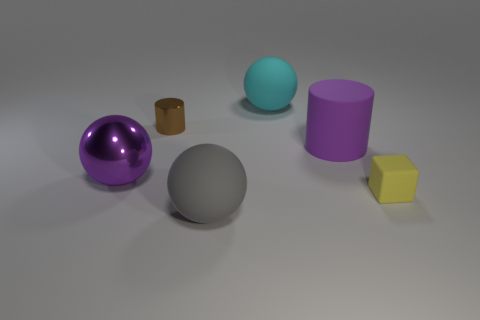Add 4 tiny shiny things. How many objects exist? 10 Subtract all cylinders. How many objects are left? 4 Subtract 0 green spheres. How many objects are left? 6 Subtract all big cyan spheres. Subtract all large matte cylinders. How many objects are left? 4 Add 6 large matte things. How many large matte things are left? 9 Add 3 metal objects. How many metal objects exist? 5 